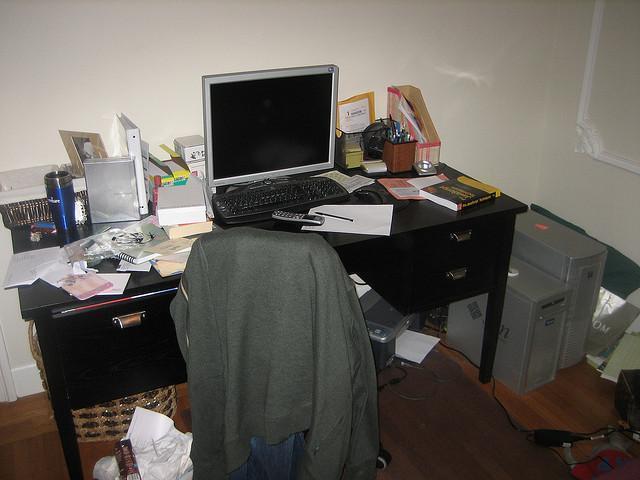What is in the room?
Select the accurate response from the four choices given to answer the question.
Options: Dog, basketball hoop, messy desk, cat. Messy desk. 